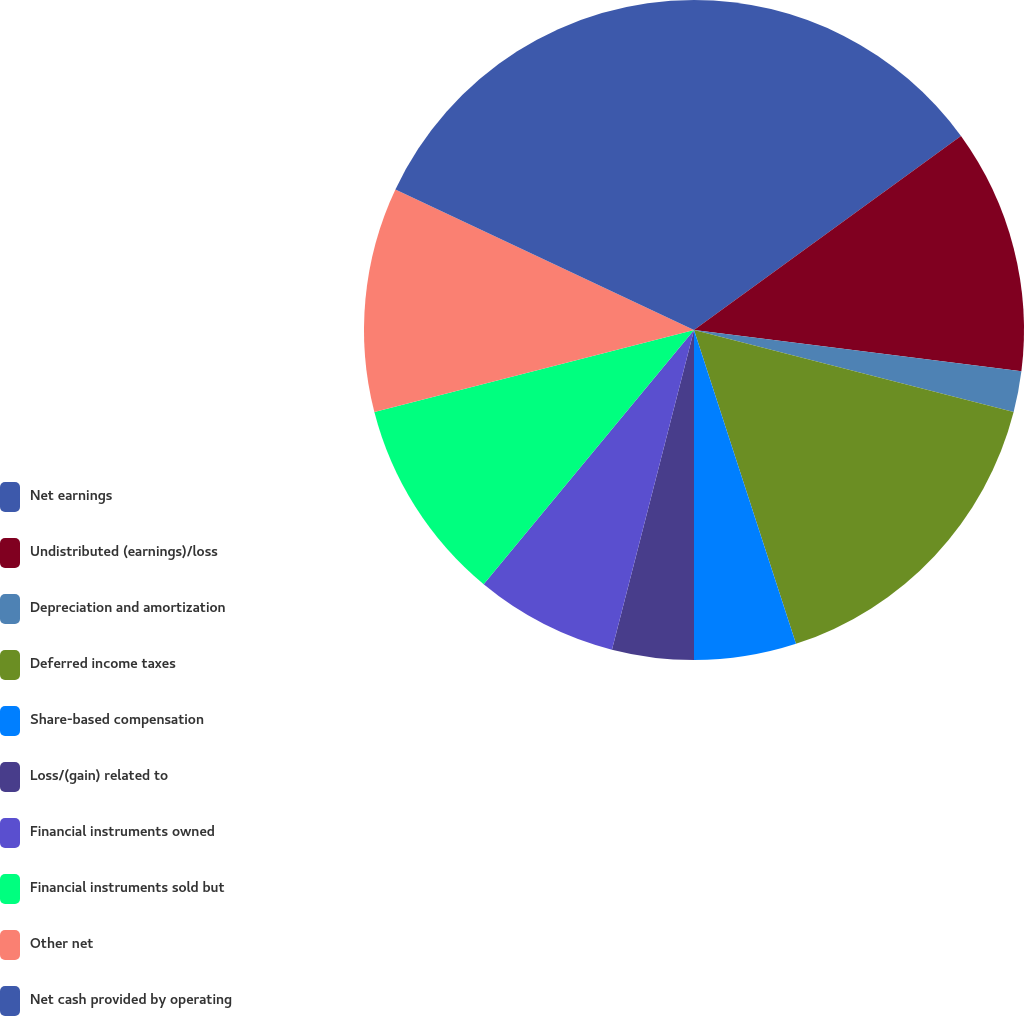Convert chart to OTSL. <chart><loc_0><loc_0><loc_500><loc_500><pie_chart><fcel>Net earnings<fcel>Undistributed (earnings)/loss<fcel>Depreciation and amortization<fcel>Deferred income taxes<fcel>Share-based compensation<fcel>Loss/(gain) related to<fcel>Financial instruments owned<fcel>Financial instruments sold but<fcel>Other net<fcel>Net cash provided by operating<nl><fcel>15.0%<fcel>12.0%<fcel>2.0%<fcel>16.0%<fcel>5.0%<fcel>4.0%<fcel>7.0%<fcel>10.0%<fcel>11.0%<fcel>18.0%<nl></chart> 